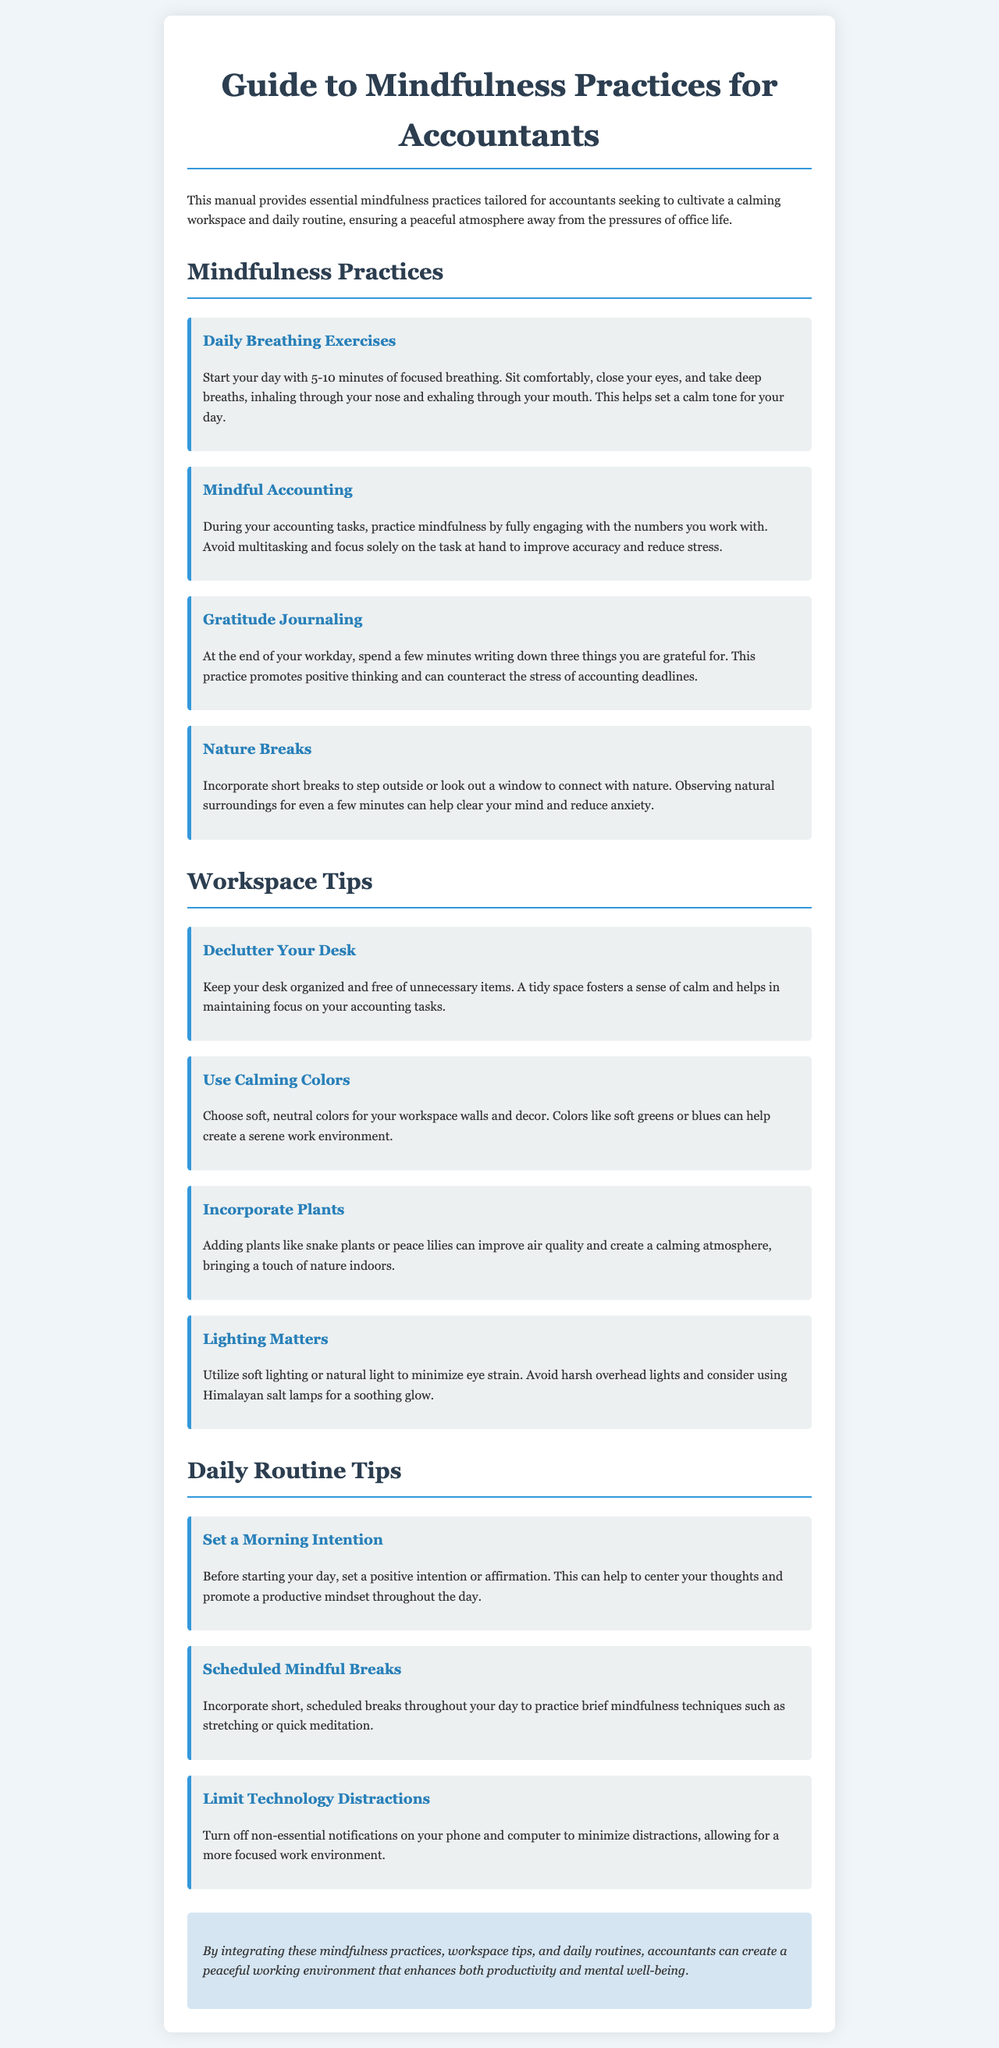What is the title of the manual? The title of the manual is clearly stated as the main heading at the top of the document.
Answer: Guide to Mindfulness Practices for Accountants How many mindfulness practices are listed in the document? The document outlines several mindfulness practices for accountants, which can be counted in the section.
Answer: Four What is one suggested mindfulness practice for accountants? The document includes various practices, one of which specifically addresses breathing techniques.
Answer: Daily Breathing Exercises What color is recommended for a calming workspace? The workspace tips section mentions specific colors that can create a serene atmosphere.
Answer: Soft greens or blues What is a tip for decluttering your desk? The manual advises on maintaining an organized desk to contribute to a calming workspace.
Answer: Keep your desk organized What should you do before starting your workday? The daily routine tips suggest setting a positive intention at the beginning of the day.
Answer: Set a Morning Intention Which types of plants are mentioned for improving office air quality? The workspace tips mention specific plants that can enhance the atmosphere in the workspace.
Answer: Snake plants or peace lilies How can you limit distractions while working? One of the recommended daily routine tips focuses on managing technology distractions.
Answer: Turn off non-essential notifications 